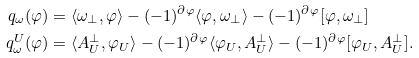<formula> <loc_0><loc_0><loc_500><loc_500>q _ { \omega } ( \varphi ) & = \langle \omega _ { \perp } , \varphi \rangle - ( - 1 ) ^ { \partial \varphi } \langle \varphi , \omega _ { \perp } \rangle - ( - 1 ) ^ { \partial \varphi } [ \varphi , \omega _ { \perp } ] \\ q _ { \omega } ^ { U } ( \varphi ) & = \langle A _ { U } ^ { \perp } , \varphi _ { U } \rangle - ( - 1 ) ^ { \partial \varphi } \langle \varphi _ { U } , A _ { U } ^ { \perp } \rangle - ( - 1 ) ^ { \partial \varphi } [ \varphi _ { U } , A _ { U } ^ { \perp } ] .</formula> 